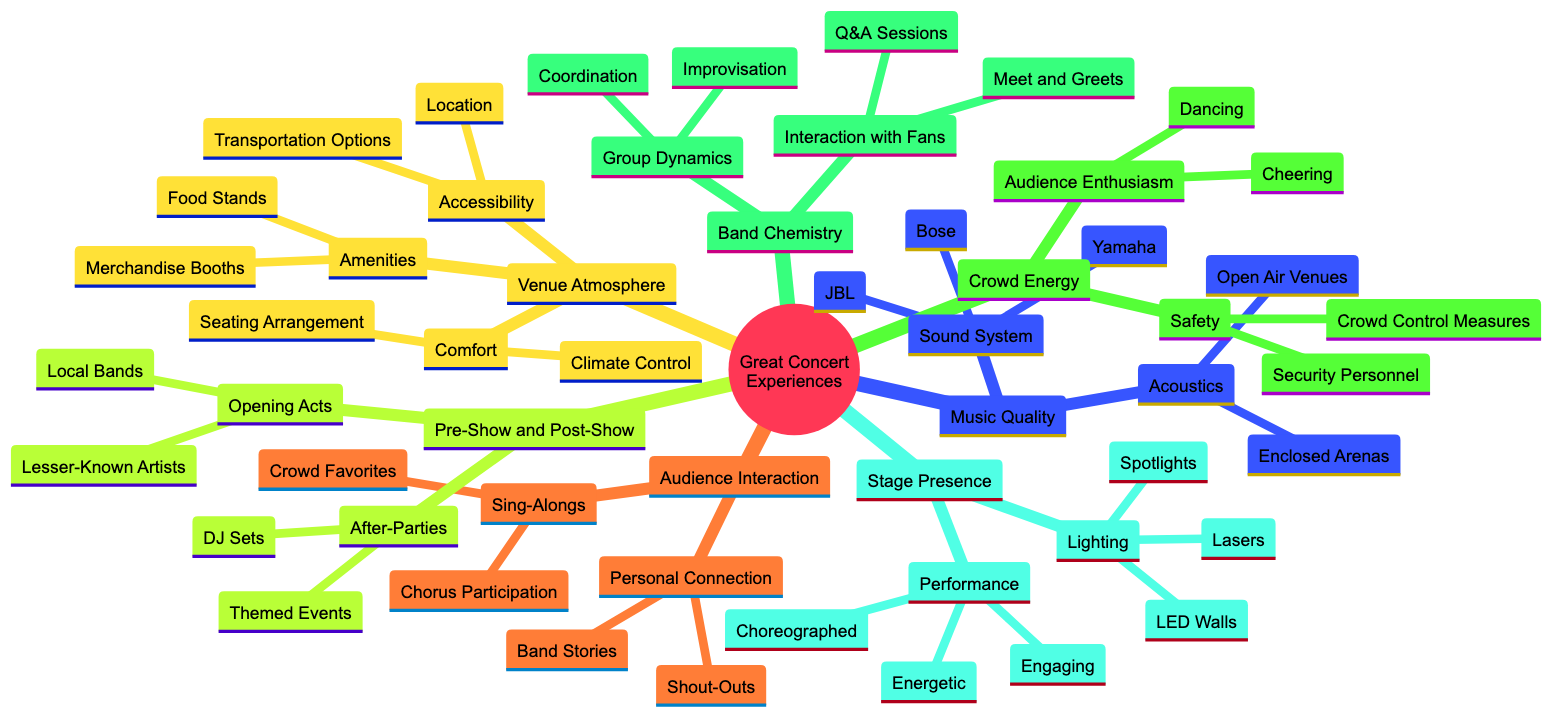What are the two types of elements under Music Quality? The main element "Music Quality" has two sub-elements: "Sound System" and "Acoustics".
Answer: Sound System, Acoustics How many types of lighting are listed under Stage Presence? The "Lighting" under "Stage Presence" includes three types: "Spotlights", "Lasers", and "LED Walls".
Answer: 3 Which sub-element in Venue Atmosphere relates to seating arrangements? The "Comfort" sub-element includes "Seating Arrangement" as one of its aspects.
Answer: Comfort What are the opening acts examples listed in Pre-Show and Post-Show Activities? Under "Opening Acts", the examples given are "Local Bands" and "Lesser-Known Artists".
Answer: Local Bands, Lesser-Known Artists How is crowd safety maintained based on the diagram? The "Safety" element under "Crowd Energy" includes "Security Personnel" and "Crowd Control Measures".
Answer: Security Personnel, Crowd Control Measures What is a key aspect of Audience Interaction highlighted? One of the main components of Audience Interaction is "Sing-Alongs", which includes "Crowd Favorites" and "Chorus Participation".
Answer: Sing-Alongs What two components make up Band Chemistry? The "Band Chemistry" element consists of "Group Dynamics" and "Interaction with Fans".
Answer: Group Dynamics, Interaction with Fans Which venue atmosphere sub-element focuses on transportation? The "Accessibility" sub-element focuses on aspects related to transportation options.
Answer: Accessibility 